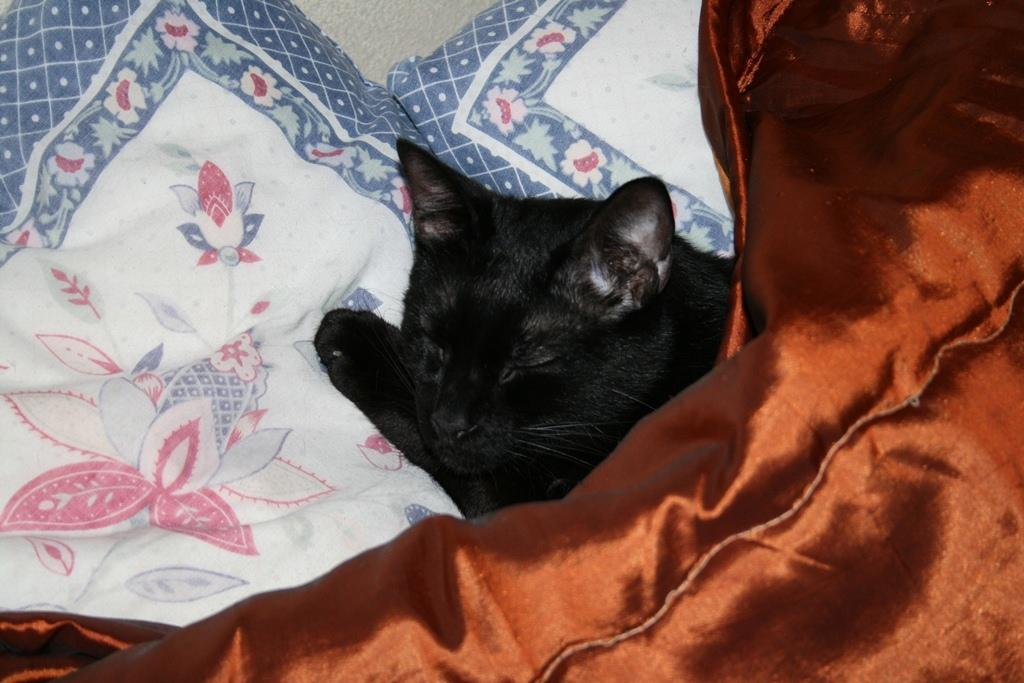What type of animal is in the picture? There is a cat in the picture. What is the cat doing in the picture? The cat is sleeping in the picture. Where is the cat located in the picture? The cat is under the bed sheet and on the pillows in the picture. What color is the cat in the picture? The cat is black in color. What month is it in the picture? The month is not mentioned or depicted in the image, so it cannot be determined from the picture. 